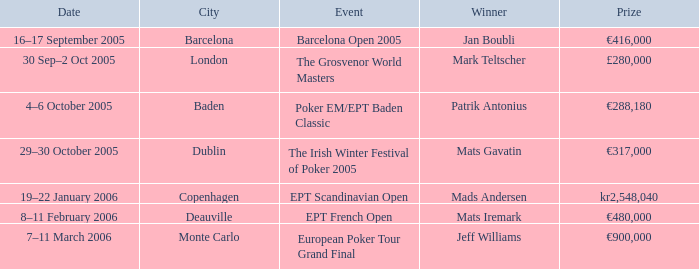What city was the event in when Patrik Antonius won? Baden. 